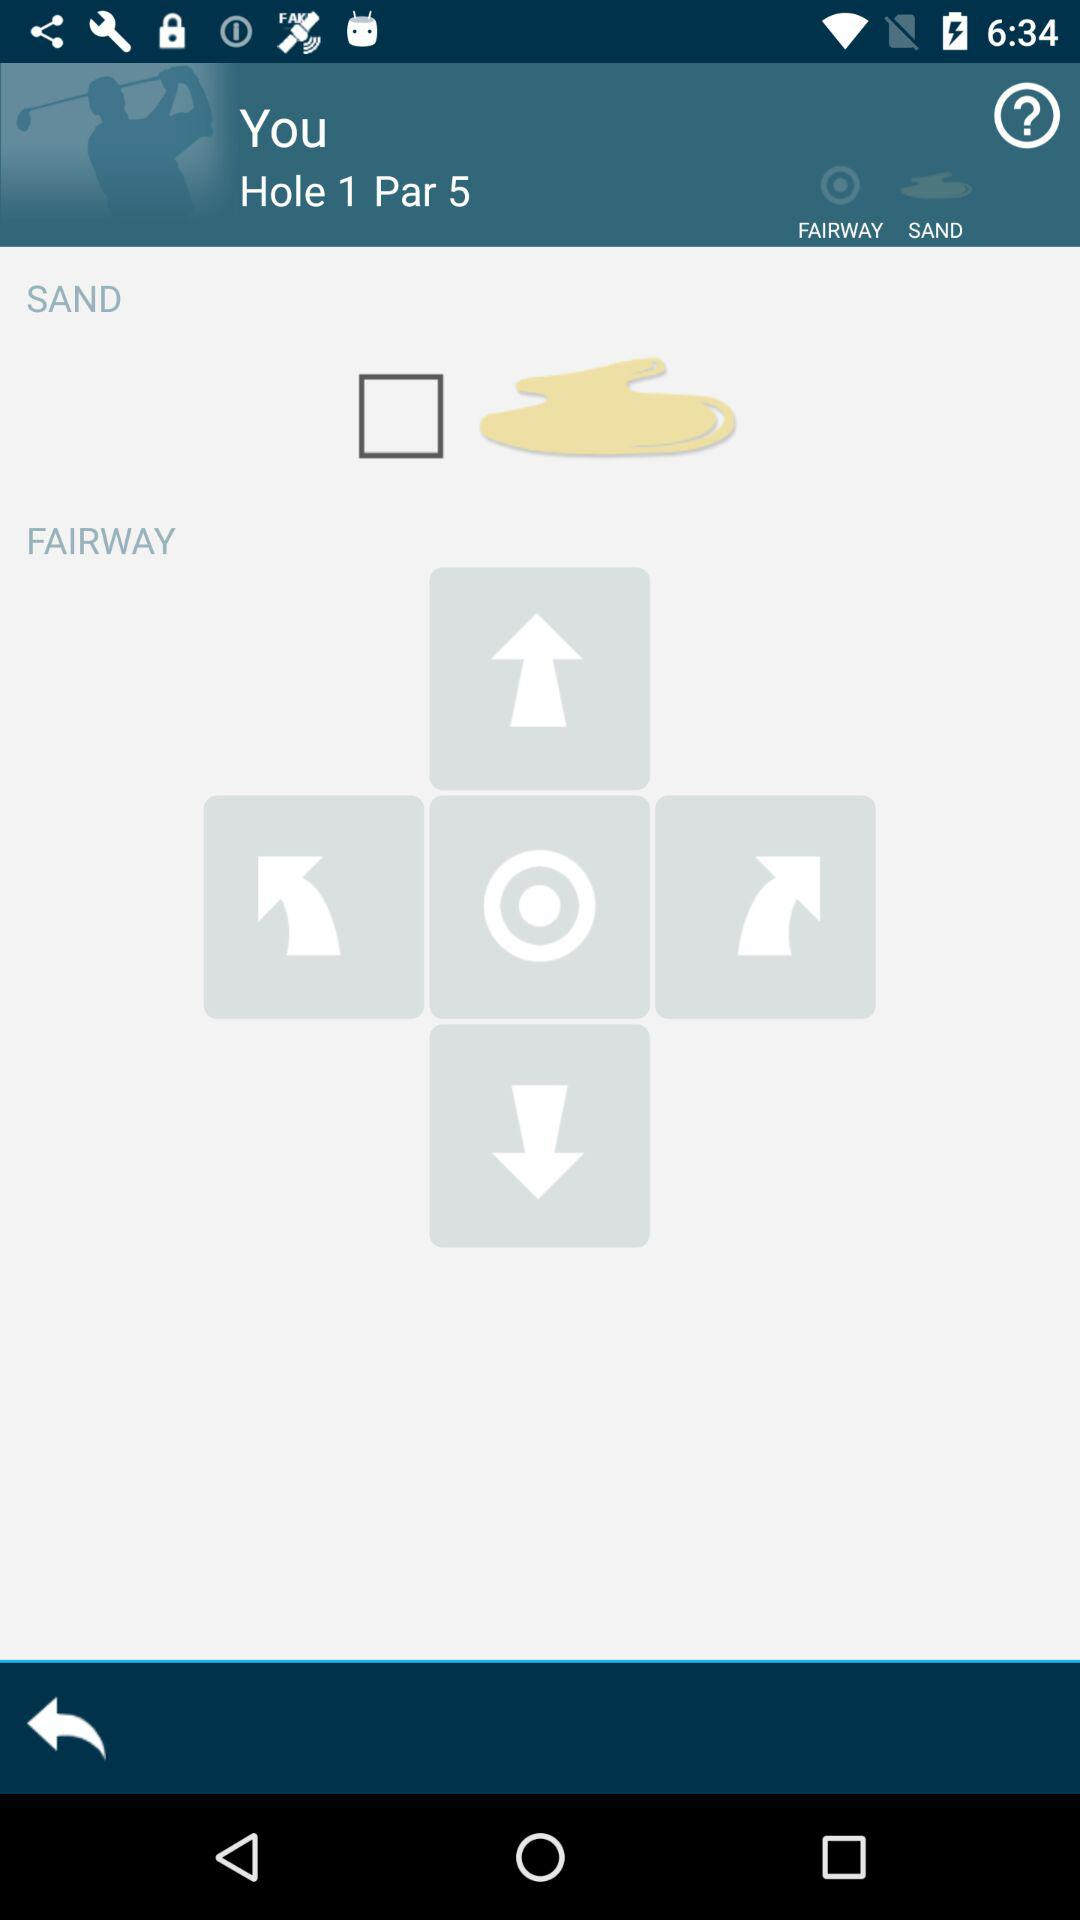What is the number of the hole? The number of the hole is 1. 